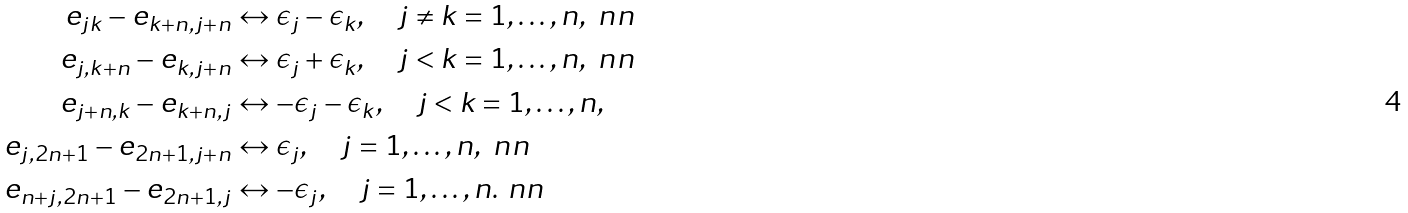<formula> <loc_0><loc_0><loc_500><loc_500>e _ { j k } - e _ { k + n , j + n } & \leftrightarrow \epsilon _ { j } - \epsilon _ { k } , \quad j \neq k = 1 , \dots , n , \ n n \\ e _ { j , k + n } - e _ { k , j + n } & \leftrightarrow \epsilon _ { j } + \epsilon _ { k } , \quad j < k = 1 , \dots , n , \ n n \\ e _ { j + n , k } - e _ { k + n , j } & \leftrightarrow - \epsilon _ { j } - \epsilon _ { k } , \quad j < k = 1 , \dots , n , \\ e _ { j , 2 n + 1 } - e _ { 2 n + 1 , j + n } & \leftrightarrow \epsilon _ { j } , \quad j = 1 , \dots , n , \ n n \\ e _ { n + j , 2 n + 1 } - e _ { 2 n + 1 , j } & \leftrightarrow - \epsilon _ { j } , \quad j = 1 , \dots , n . \ n n</formula> 